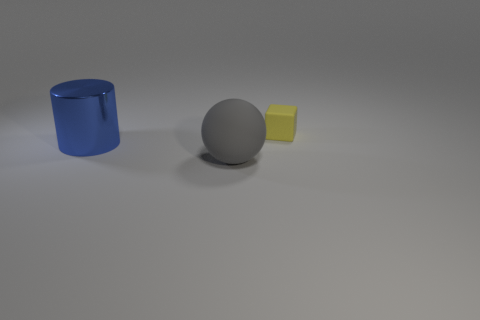Are there fewer small gray metal blocks than objects?
Keep it short and to the point. Yes. There is a large thing that is in front of the big object behind the rubber ball; what is its shape?
Offer a very short reply. Sphere. What shape is the other thing that is the same size as the blue thing?
Give a very brief answer. Sphere. What material is the blue cylinder?
Keep it short and to the point. Metal. There is a small yellow object; are there any big blue things in front of it?
Offer a very short reply. Yes. There is a large thing that is left of the gray matte object; what number of large cylinders are in front of it?
Provide a short and direct response. 0. There is a object that is the same size as the matte ball; what is its material?
Give a very brief answer. Metal. How many other objects are there of the same material as the small object?
Give a very brief answer. 1. How many blue shiny objects are to the right of the cylinder?
Provide a short and direct response. 0. How many cubes are either big blue shiny objects or big gray matte objects?
Your answer should be very brief. 0. 